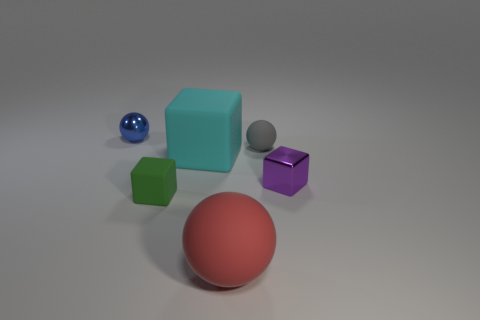Add 4 small blocks. How many objects exist? 10 Add 3 large cyan things. How many large cyan things exist? 4 Subtract 0 purple balls. How many objects are left? 6 Subtract all tiny blue metal objects. Subtract all blue metallic balls. How many objects are left? 4 Add 5 green blocks. How many green blocks are left? 6 